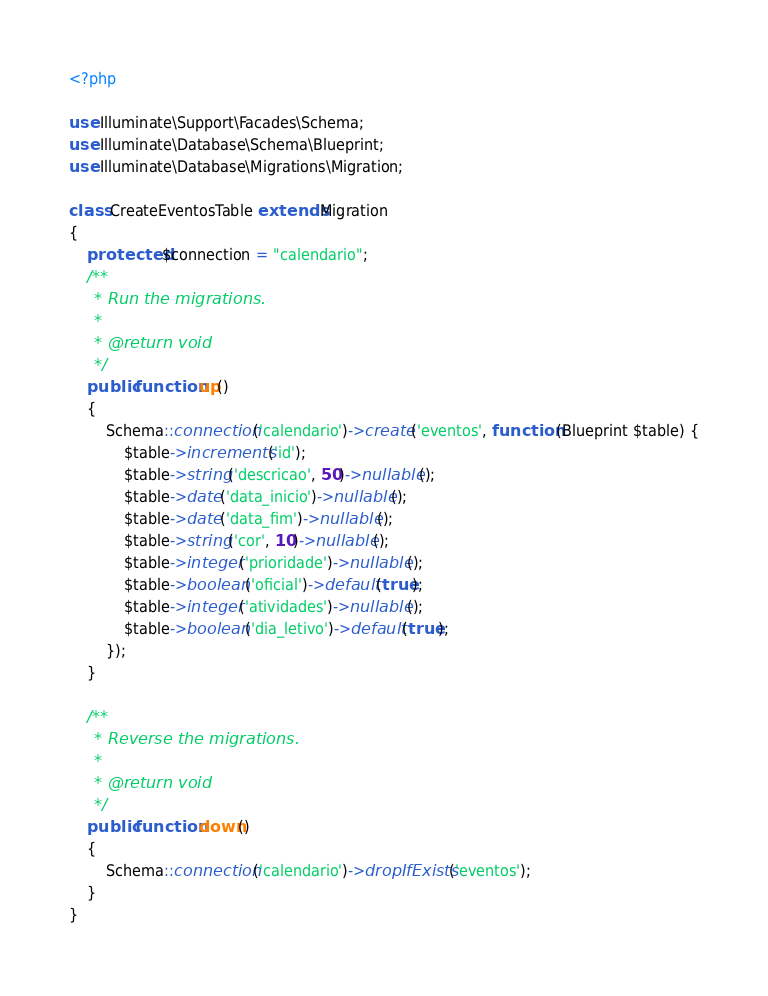Convert code to text. <code><loc_0><loc_0><loc_500><loc_500><_PHP_><?php

use Illuminate\Support\Facades\Schema;
use Illuminate\Database\Schema\Blueprint;
use Illuminate\Database\Migrations\Migration;

class CreateEventosTable extends Migration
{
    protected $connection = "calendario";
    /**
     * Run the migrations.
     *
     * @return void
     */
    public function up()
    {
        Schema::connection('calendario')->create('eventos', function (Blueprint $table) {
            $table->increments('id');
            $table->string('descricao', 50)->nullable();
            $table->date('data_inicio')->nullable();
            $table->date('data_fim')->nullable();
            $table->string('cor', 10)->nullable();
            $table->integer('prioridade')->nullable();
            $table->boolean('oficial')->default(true);
            $table->integer('atividades')->nullable();
            $table->boolean('dia_letivo')->default(true);
        });
    }

    /**
     * Reverse the migrations.
     *
     * @return void
     */
    public function down()
    {
        Schema::connection('calendario')->dropIfExists('eventos');
    }
}
</code> 